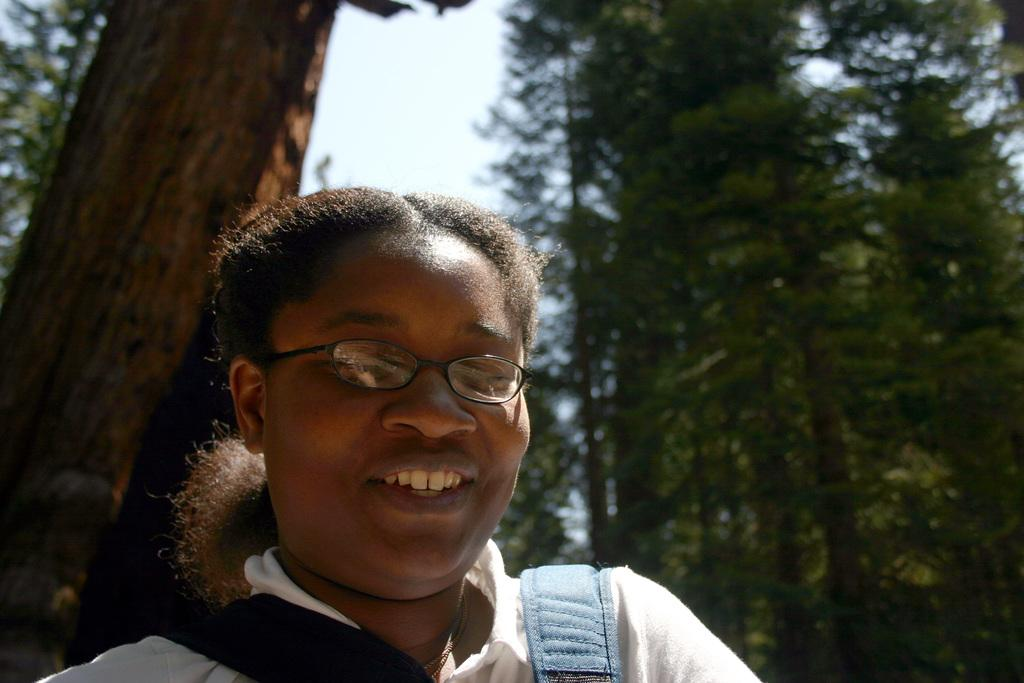Who is the main subject in the image? There is a girl in the image. What is the girl's expression in the image? The girl is smiling in the image. What can be seen in the background of the image? There are trees and the sky visible in the background of the image. What thing is the girl smashing with her temper in the image? There is no indication in the image that the girl is smashing anything or displaying a temper. 